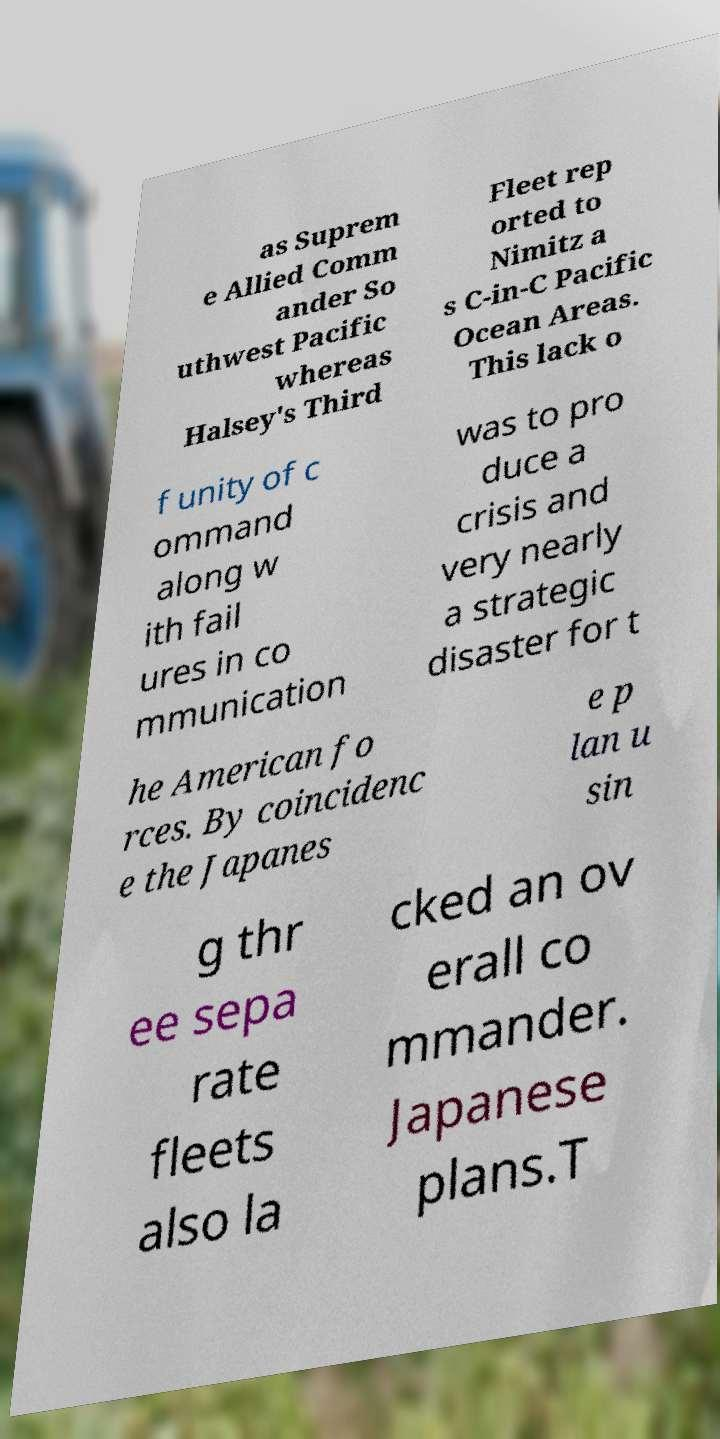Could you extract and type out the text from this image? as Suprem e Allied Comm ander So uthwest Pacific whereas Halsey's Third Fleet rep orted to Nimitz a s C-in-C Pacific Ocean Areas. This lack o f unity of c ommand along w ith fail ures in co mmunication was to pro duce a crisis and very nearly a strategic disaster for t he American fo rces. By coincidenc e the Japanes e p lan u sin g thr ee sepa rate fleets also la cked an ov erall co mmander. Japanese plans.T 